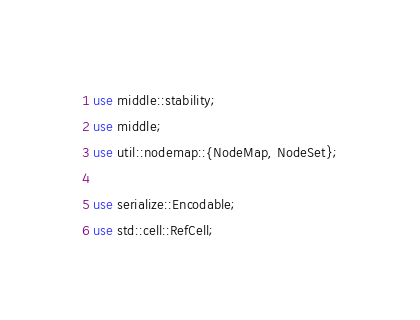Convert code to text. <code><loc_0><loc_0><loc_500><loc_500><_Rust_>use middle::stability;
use middle;
use util::nodemap::{NodeMap, NodeSet};

use serialize::Encodable;
use std::cell::RefCell;</code> 